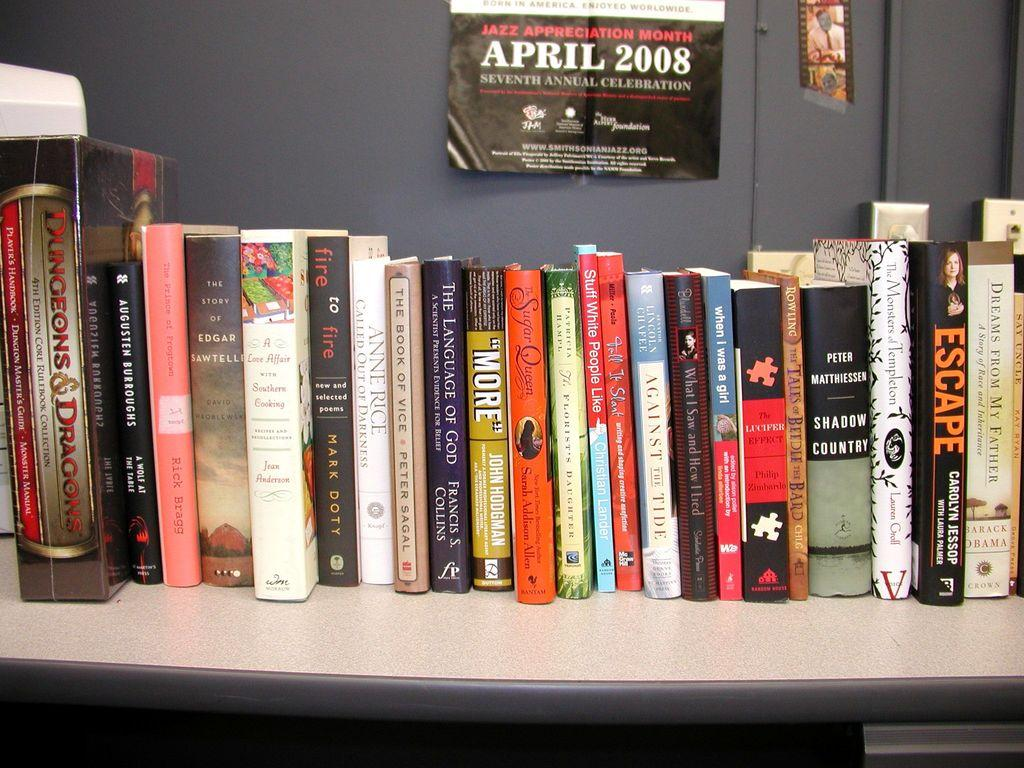<image>
Describe the image concisely. A number of books on a shelf such as the book Shadow Country. 